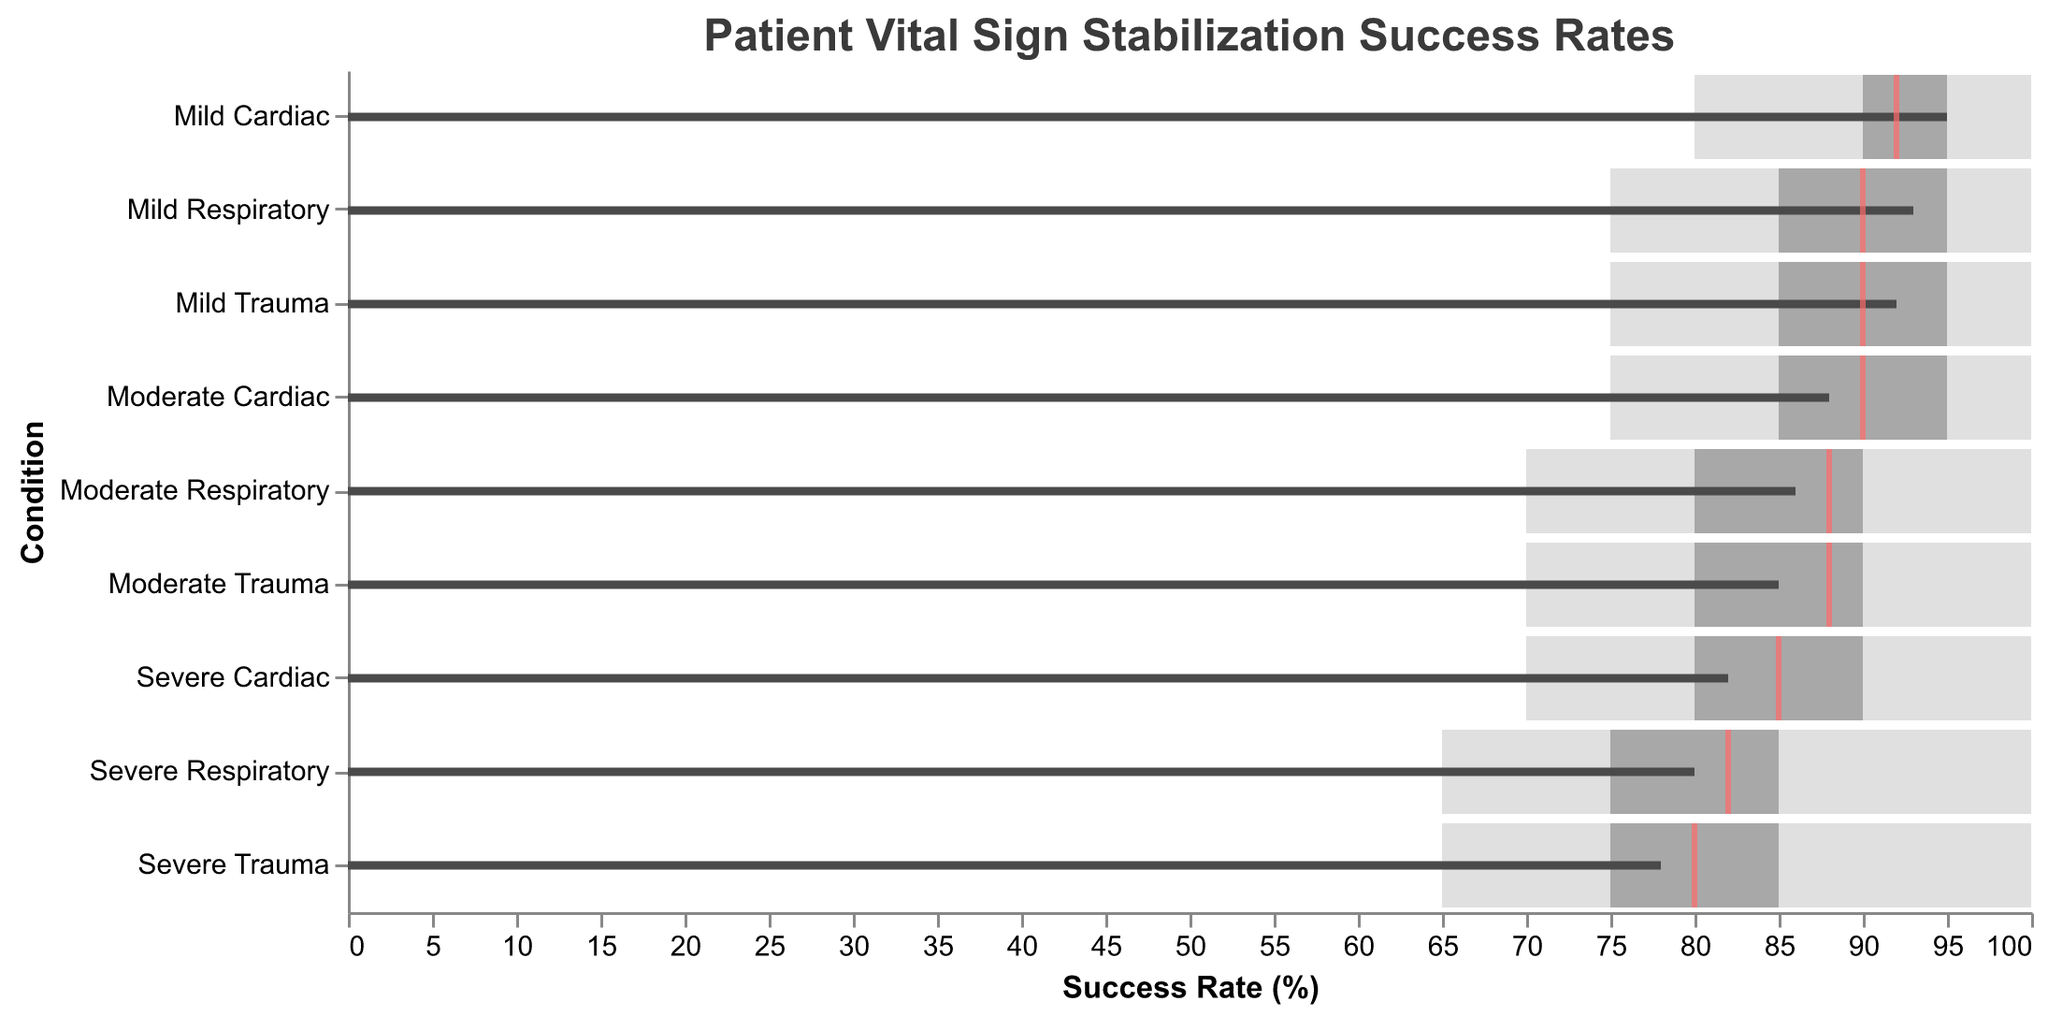What is the title of the chart? The title of the chart is displayed at the top of the figure and gives an overall description of what the chart represents.
Answer: Patient Vital Sign Stabilization Success Rates What is the success rate for Mild Trauma compared to its target? The success rate for Mild Trauma is represented by the black bar for "Actual" and the red tick for "Target". Both values can be directly read from the figure.
Answer: 92 vs 90 Which condition has the highest actual success rate? By comparing the values of the black bars representing "Actual" success rates for each condition, the one with the highest value is identified.
Answer: Mild Cardiac How many conditions have an actual success rate below their target? By comparing the "Actual" success rates (black bars) with their respective targets (red ticks), count the number of conditions where "Actual" is less than "Target".
Answer: 4 Which conditions fall within the "Excellent" range? The "Excellent" range is the highest range marked by the background color. Conditions with "Actual" success rates (black bars) that fall into this range are identified.
Answer: Mild Trauma, Mild Cardiac, Mild Respiratory Which condition exceeds the 'Good' but not 'Excellent'? Identify conditions where the "Actual" success rate falls between the "Good" and "Excellent" ranges by comparing the black bars with the background color divisions.
Answer: None How do the success rates for Moderate and Severe Cardiac conditions compare? Directly compare the "Actual" success rates (black bars) for Moderate and Severe Cardiac to see which is higher.
Answer: Moderate Cardiac (88) vs Severe Cardiac (82) Which condition has the largest gap between its poor and excellent thresholds? Calculate the range by subtracting "Poor" from "Excellent" for each condition and determine which has the largest gap.
Answer: All conditions have consistent gaps of 35 For which conditions does the actual success rate fall into the satisfactory range? Compare the "Actual" success rates with the defined ranges for "Poor," "Satisfactory," "Good," and "Excellent" to see where the black bar falls.
Answer: Moderate Trauma, Severe Cardiac, Severe Respiratory 